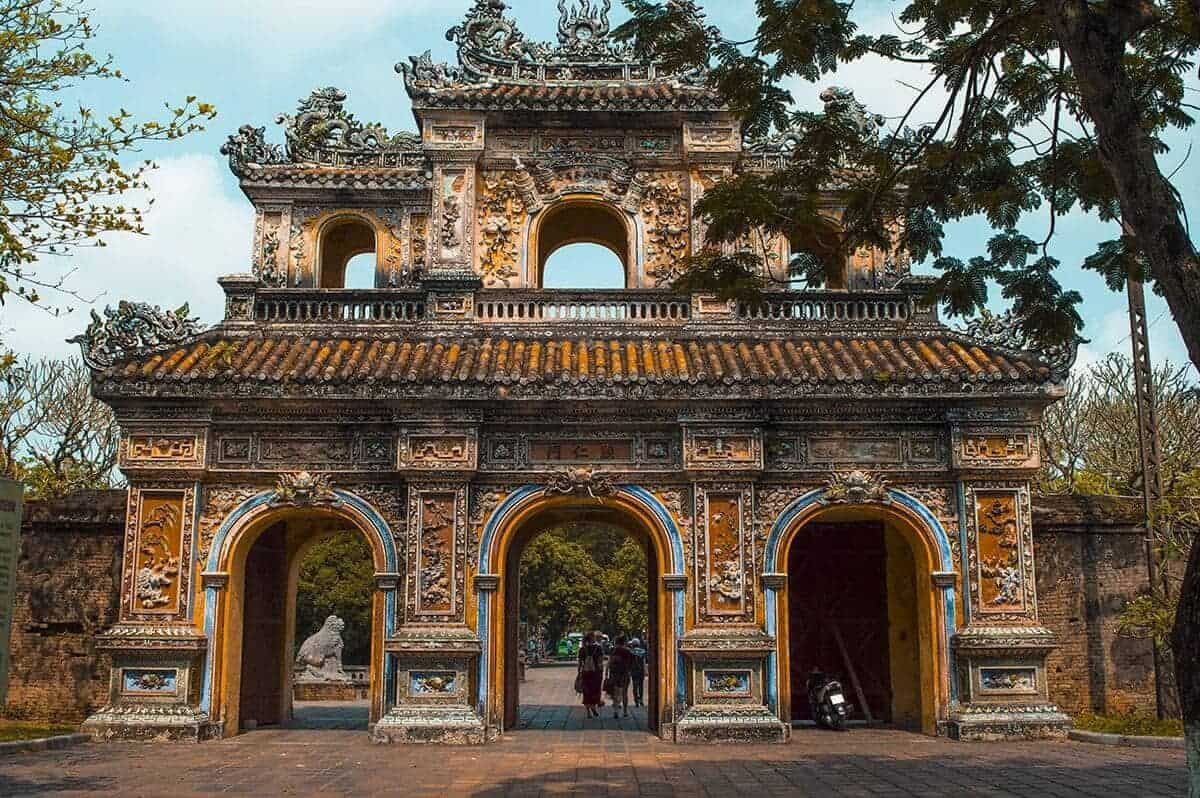Can you explain the architectural styles visible in this gate? Certainly! The gate of the Imperial Citadel of Hue is a prime example of traditional Vietnamese architecture, influenced by both Asian and French colonial elements. The structure primarily reflects the Vietnamese Nguyen architectural style which is known for its symmetry and importance of central axis. The gate features a wide array of decorations including ceramic mosaics made up of broken porcelain and glass, a technique often used in Vietnamese sacred buildings. The ornate carvings and statues that embellish the gate include floral motifs, mythical creatures like dragons, and scenes from folk tales, which are emblematic of east Asian cultural symbolism. The vibrant colors and elaborate decorations not only exhibit aesthetic beauty but also convey cultural significance, reflecting the power and spirituality associated with the Nguyen dynasty rulers. 